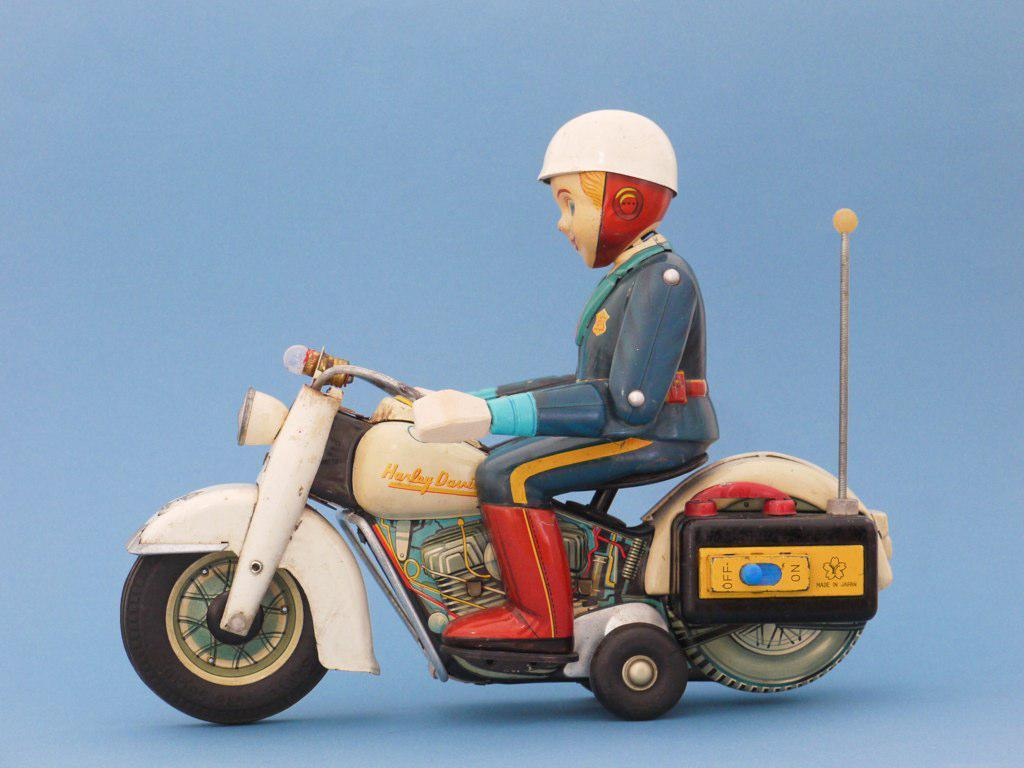What type of object can be seen in the image? There is a toy in the image. What mode of transportation is also visible in the image? There is a bike in the image. How is the person dressed in the image? The person is wearing a blue and red dress. What color is the bike in the image? The bike is white. What color is the background of the image? The background of the image is blue. What type of meat is being served in the image? There is no meat present in the image. What tax-related information can be found in the image? There is no tax-related information in the image. 